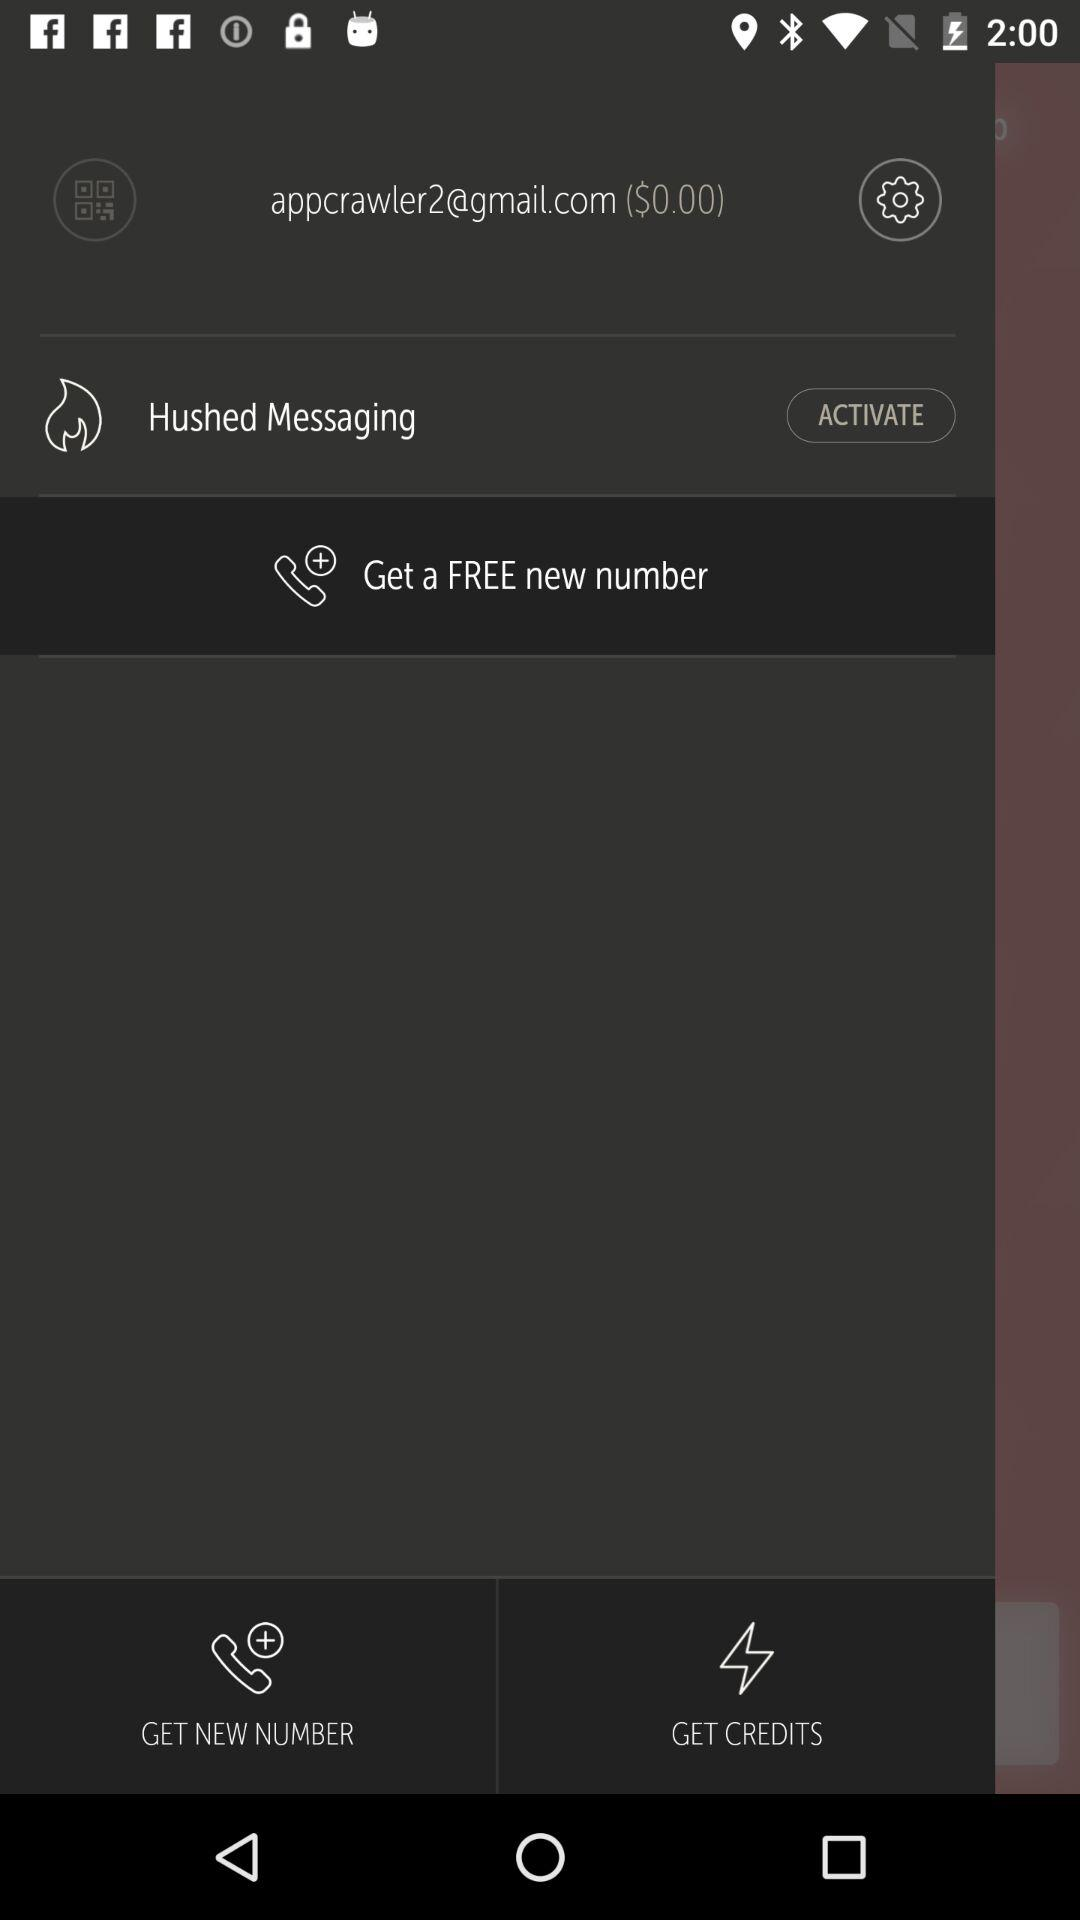What is the amount shown on the screen? The amount shown on the screen is $0. 